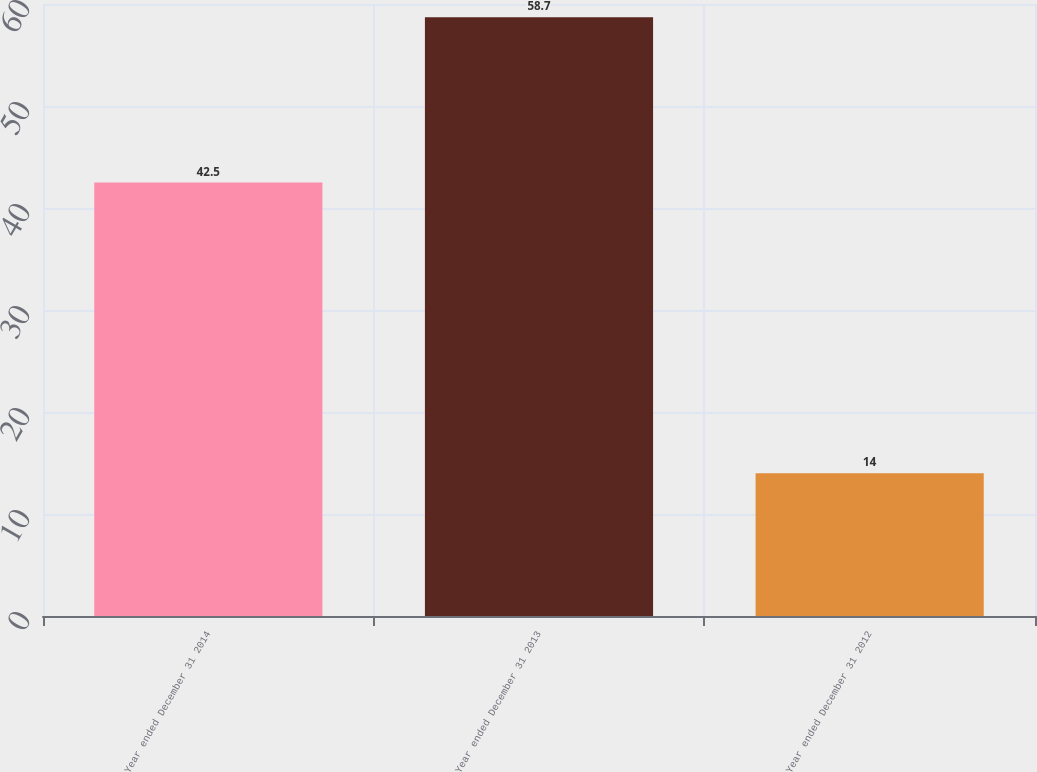Convert chart to OTSL. <chart><loc_0><loc_0><loc_500><loc_500><bar_chart><fcel>Year ended December 31 2014<fcel>Year ended December 31 2013<fcel>Year ended December 31 2012<nl><fcel>42.5<fcel>58.7<fcel>14<nl></chart> 